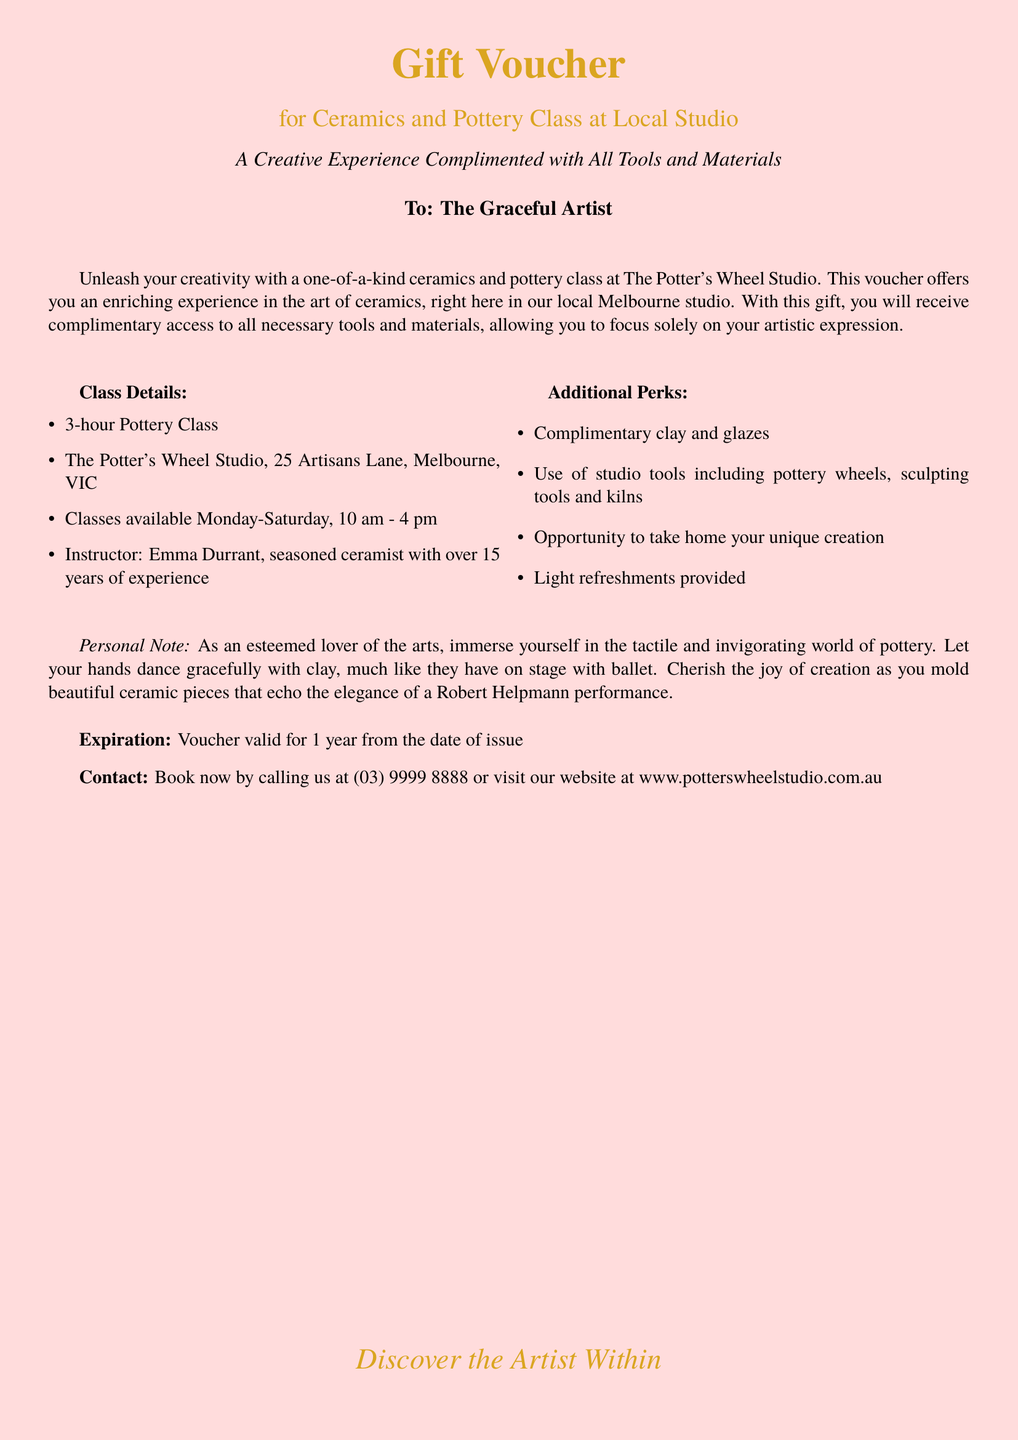What is the duration of the pottery class? The duration of the class is specified in the document as a 3-hour Pottery Class.
Answer: 3-hour Where is the pottery class located? The document provides the address of the studio as The Potter's Wheel Studio, 25 Artisans Lane, Melbourne, VIC.
Answer: 25 Artisans Lane, Melbourne, VIC Who is the instructor of the class? The instructor's name and experience are mentioned in the document; she is Emma Durrant with over 15 years of experience.
Answer: Emma Durrant What days can the class be attended? The document lists the available days for classes, which are Monday to Saturday.
Answer: Monday-Saturday What type of refreshments are provided? The document specifies that light refreshments are provided during the class.
Answer: Light refreshments How long is the voucher valid for? The validity period of the voucher is stated clearly in the document, which is 1 year from the date of issue.
Answer: 1 year What tools are included in the class experience? The document mentions that complimentary access includes pottery wheels, sculpting tools, and kilns.
Answer: pottery wheels, sculpting tools, and kilns Is there an opportunity to take creations home? The document confirms that there is an opportunity to take home your unique creation.
Answer: Yes What is the contact number to book the class? The contact number for bookings is explicitly provided in the document as (03) 9999 8888.
Answer: (03) 9999 8888 